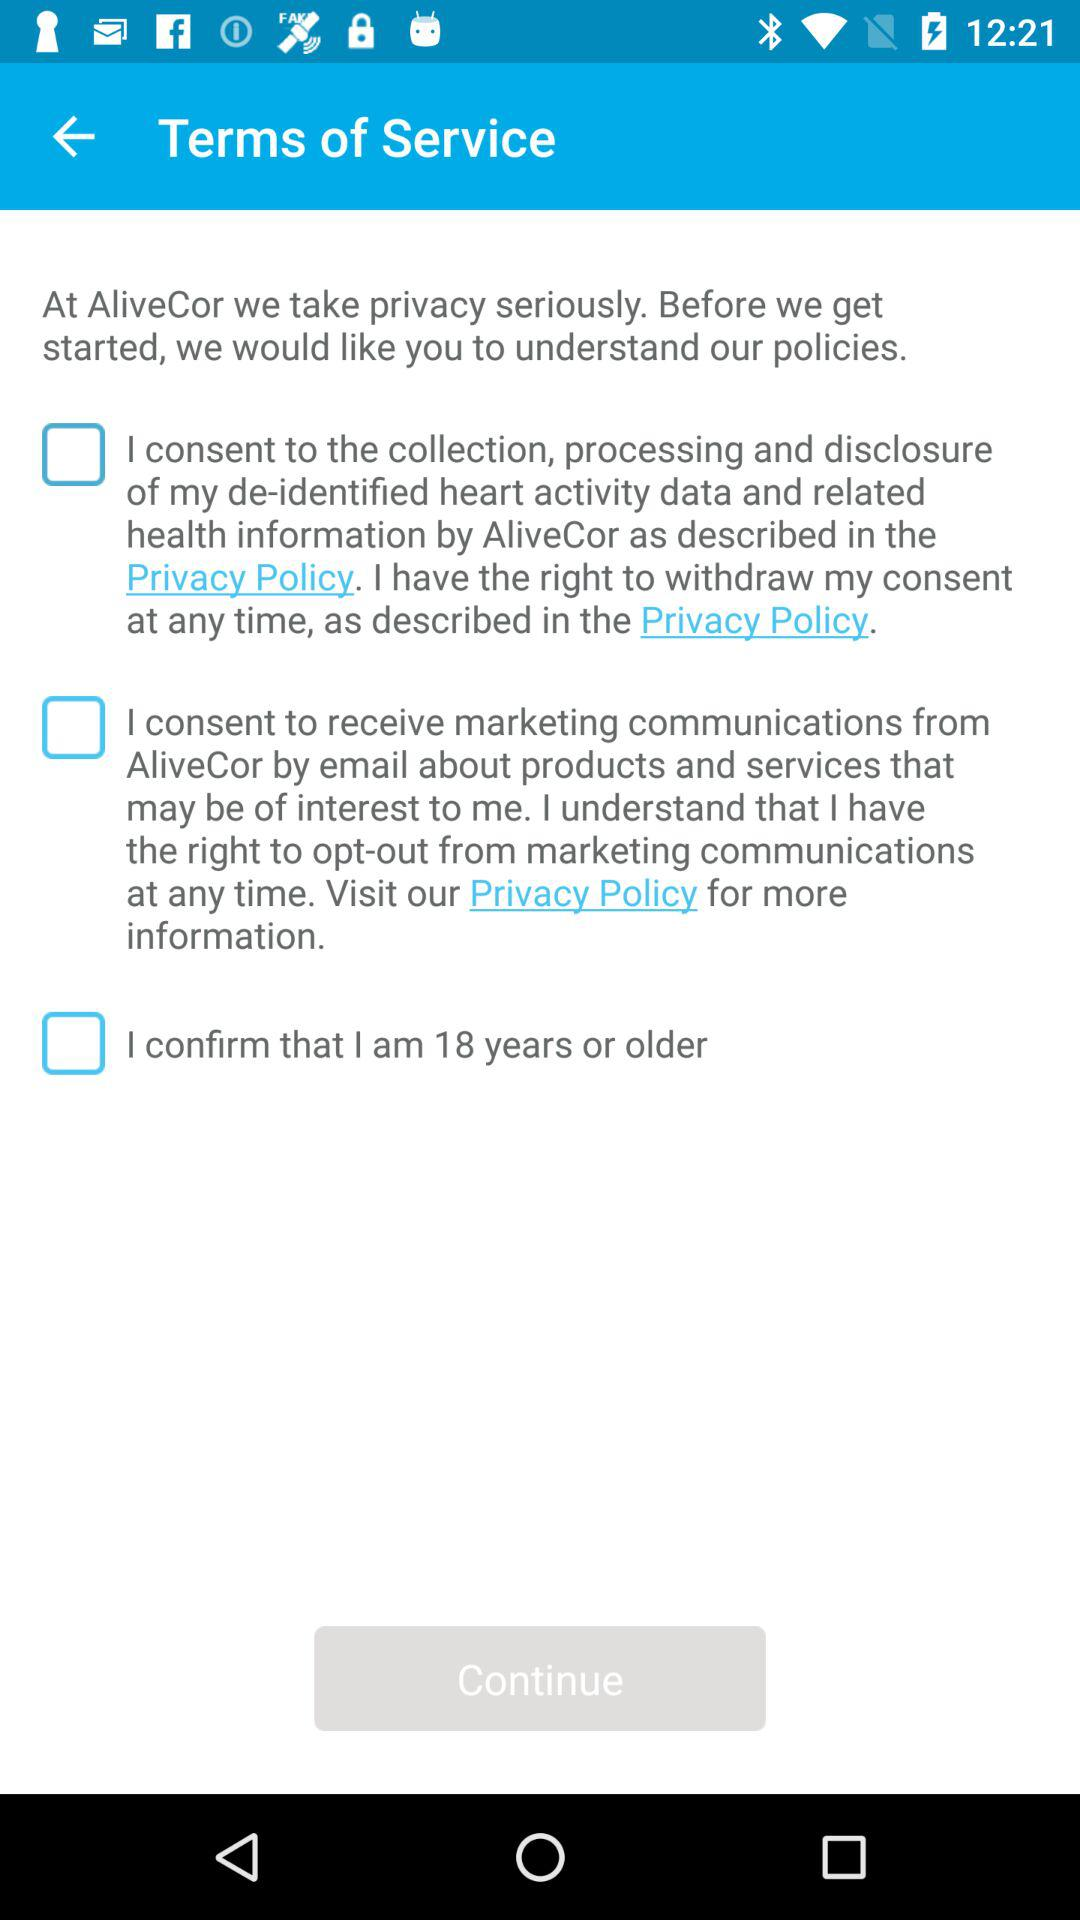What is the minimum age of confirmation? The minimum age is 18 years. 